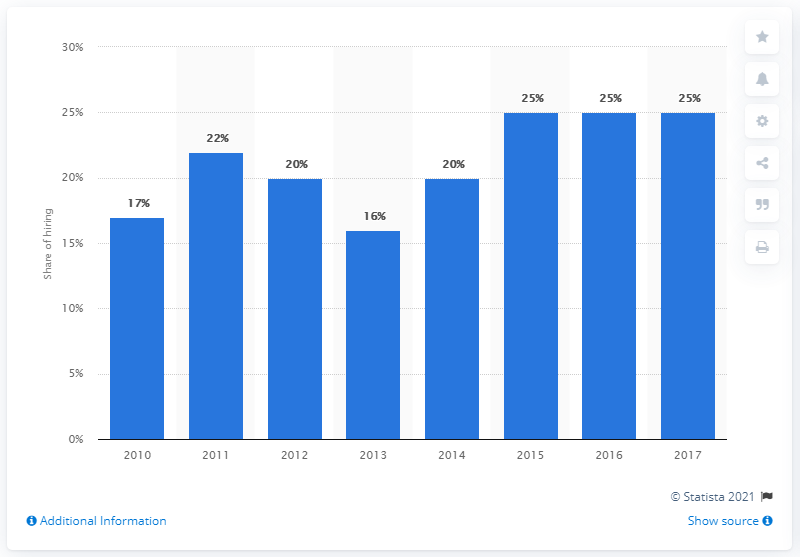Outline some significant characteristics in this image. By 2017, it was reported that 25% of small business owners indicated that they were planning to hire new staff members. 